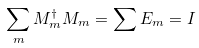<formula> <loc_0><loc_0><loc_500><loc_500>\sum _ { m } M _ { m } ^ { \dagger } M _ { m } = \sum E _ { m } = I</formula> 